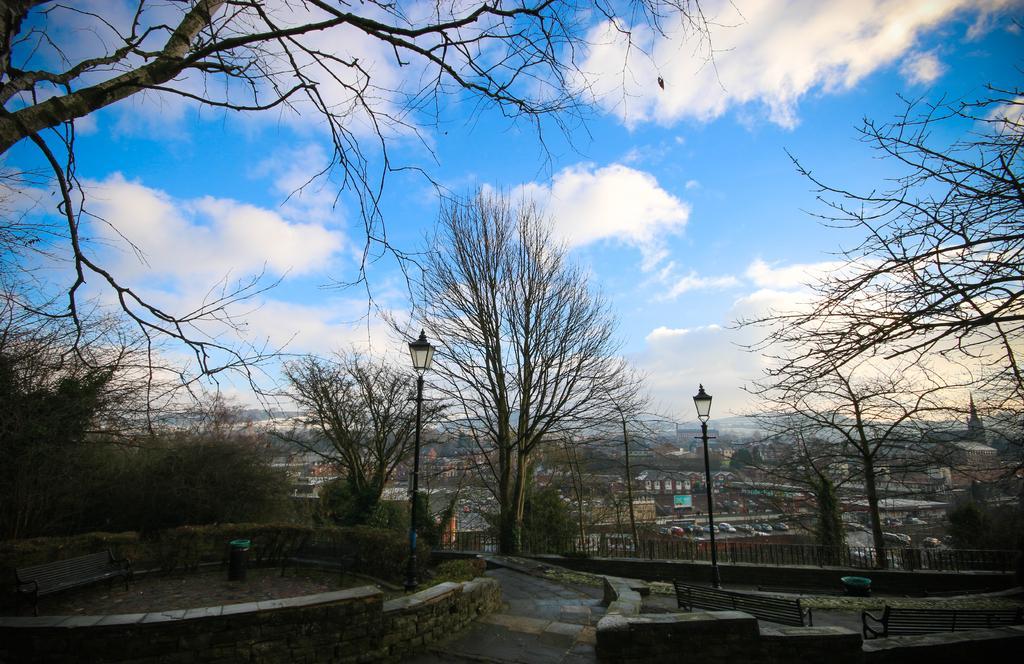Can you describe this image briefly? In this image I see number of trees, path, benches and I see 2 light poles over here and in the background I see number of buildings and the sky which is of white and blue in color. 